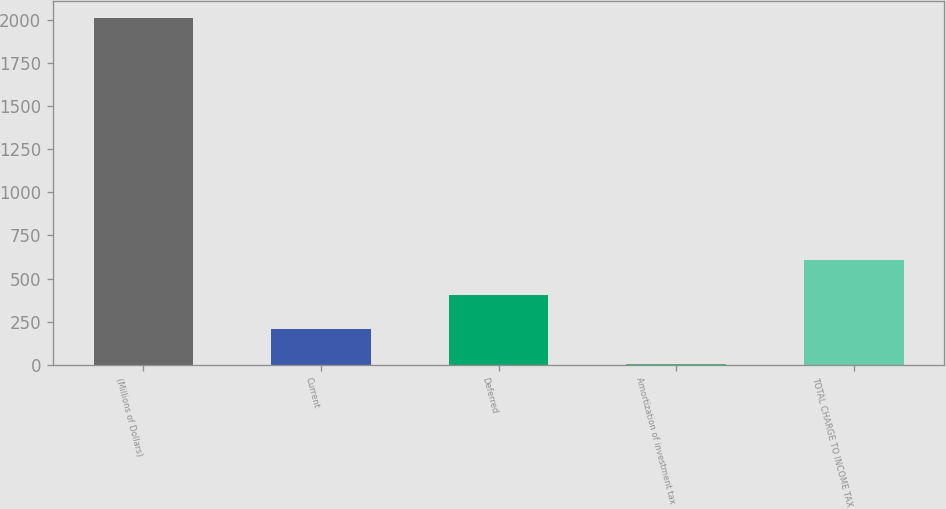Convert chart to OTSL. <chart><loc_0><loc_0><loc_500><loc_500><bar_chart><fcel>(Millions of Dollars)<fcel>Current<fcel>Deferred<fcel>Amortization of investment tax<fcel>TOTAL CHARGE TO INCOME TAX<nl><fcel>2010<fcel>206.4<fcel>406.8<fcel>6<fcel>607.2<nl></chart> 